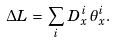<formula> <loc_0><loc_0><loc_500><loc_500>\Delta L \, = \, \sum _ { i } \, { D ^ { i } _ { x } \, \theta _ { x } ^ { i } } .</formula> 